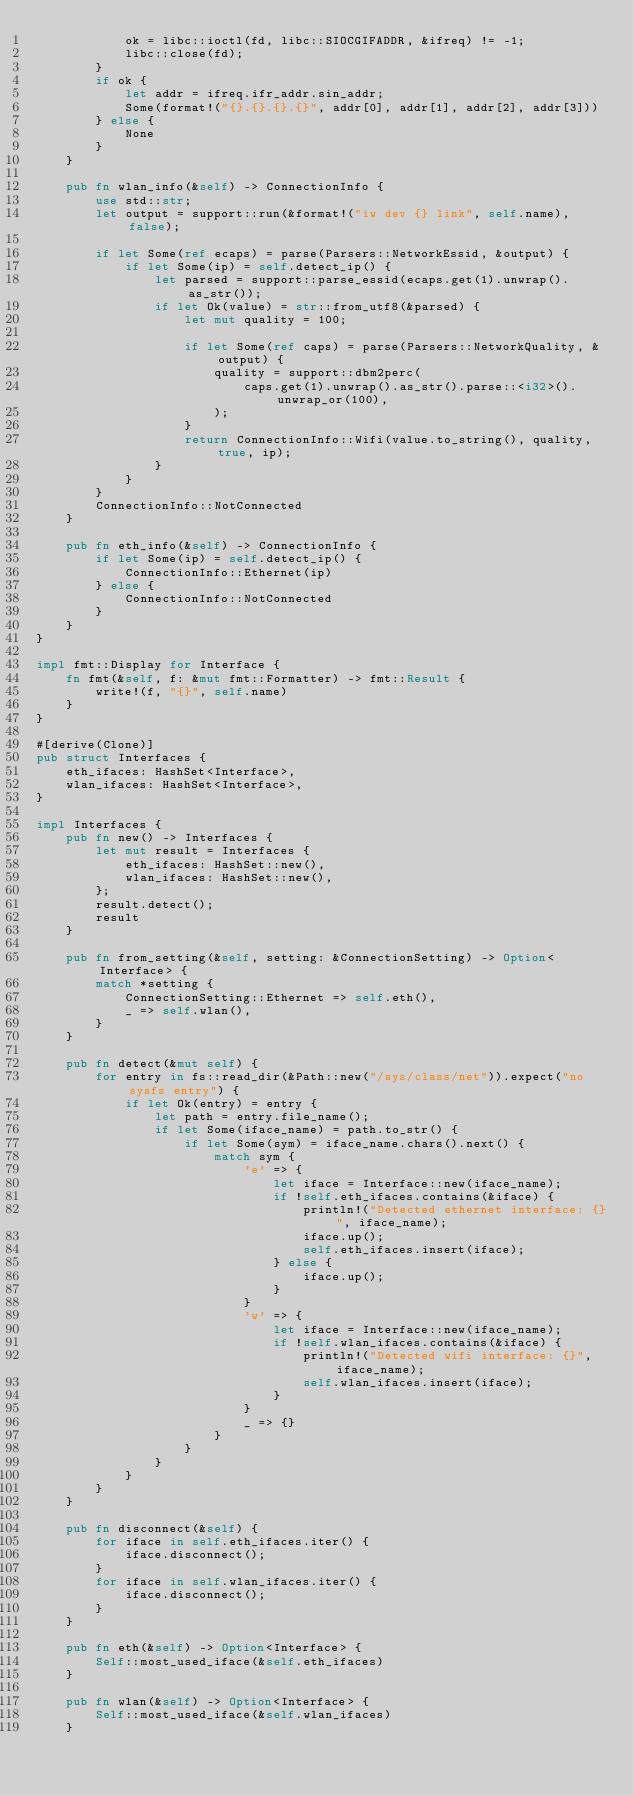Convert code to text. <code><loc_0><loc_0><loc_500><loc_500><_Rust_>            ok = libc::ioctl(fd, libc::SIOCGIFADDR, &ifreq) != -1;
            libc::close(fd);
        }
        if ok {
            let addr = ifreq.ifr_addr.sin_addr;
            Some(format!("{}.{}.{}.{}", addr[0], addr[1], addr[2], addr[3]))
        } else {
            None
        }
    }

    pub fn wlan_info(&self) -> ConnectionInfo {
        use std::str;
        let output = support::run(&format!("iw dev {} link", self.name), false);

        if let Some(ref ecaps) = parse(Parsers::NetworkEssid, &output) {
            if let Some(ip) = self.detect_ip() {
                let parsed = support::parse_essid(ecaps.get(1).unwrap().as_str());
                if let Ok(value) = str::from_utf8(&parsed) {
                    let mut quality = 100;

                    if let Some(ref caps) = parse(Parsers::NetworkQuality, &output) {
                        quality = support::dbm2perc(
                            caps.get(1).unwrap().as_str().parse::<i32>().unwrap_or(100),
                        );
                    }
                    return ConnectionInfo::Wifi(value.to_string(), quality, true, ip);
                }
            }
        }
        ConnectionInfo::NotConnected
    }

    pub fn eth_info(&self) -> ConnectionInfo {
        if let Some(ip) = self.detect_ip() {
            ConnectionInfo::Ethernet(ip)
        } else {
            ConnectionInfo::NotConnected
        }
    }
}

impl fmt::Display for Interface {
    fn fmt(&self, f: &mut fmt::Formatter) -> fmt::Result {
        write!(f, "{}", self.name)
    }
}

#[derive(Clone)]
pub struct Interfaces {
    eth_ifaces: HashSet<Interface>,
    wlan_ifaces: HashSet<Interface>,
}

impl Interfaces {
    pub fn new() -> Interfaces {
        let mut result = Interfaces {
            eth_ifaces: HashSet::new(),
            wlan_ifaces: HashSet::new(),
        };
        result.detect();
        result
    }

    pub fn from_setting(&self, setting: &ConnectionSetting) -> Option<Interface> {
        match *setting {
            ConnectionSetting::Ethernet => self.eth(),
            _ => self.wlan(),
        }
    }

    pub fn detect(&mut self) {
        for entry in fs::read_dir(&Path::new("/sys/class/net")).expect("no sysfs entry") {
            if let Ok(entry) = entry {
                let path = entry.file_name();
                if let Some(iface_name) = path.to_str() {
                    if let Some(sym) = iface_name.chars().next() {
                        match sym {
                            'e' => {
                                let iface = Interface::new(iface_name);
                                if !self.eth_ifaces.contains(&iface) {
                                    println!("Detected ethernet interface: {}", iface_name);
                                    iface.up();
                                    self.eth_ifaces.insert(iface);
                                } else {
                                    iface.up();
                                }
                            }
                            'w' => {
                                let iface = Interface::new(iface_name);
                                if !self.wlan_ifaces.contains(&iface) {
                                    println!("Detected wifi interface: {}", iface_name);
                                    self.wlan_ifaces.insert(iface);
                                }
                            }
                            _ => {}
                        }
                    }
                }
            }
        }
    }

    pub fn disconnect(&self) {
        for iface in self.eth_ifaces.iter() {
            iface.disconnect();
        }
        for iface in self.wlan_ifaces.iter() {
            iface.disconnect();
        }
    }

    pub fn eth(&self) -> Option<Interface> {
        Self::most_used_iface(&self.eth_ifaces)
    }

    pub fn wlan(&self) -> Option<Interface> {
        Self::most_used_iface(&self.wlan_ifaces)
    }
</code> 